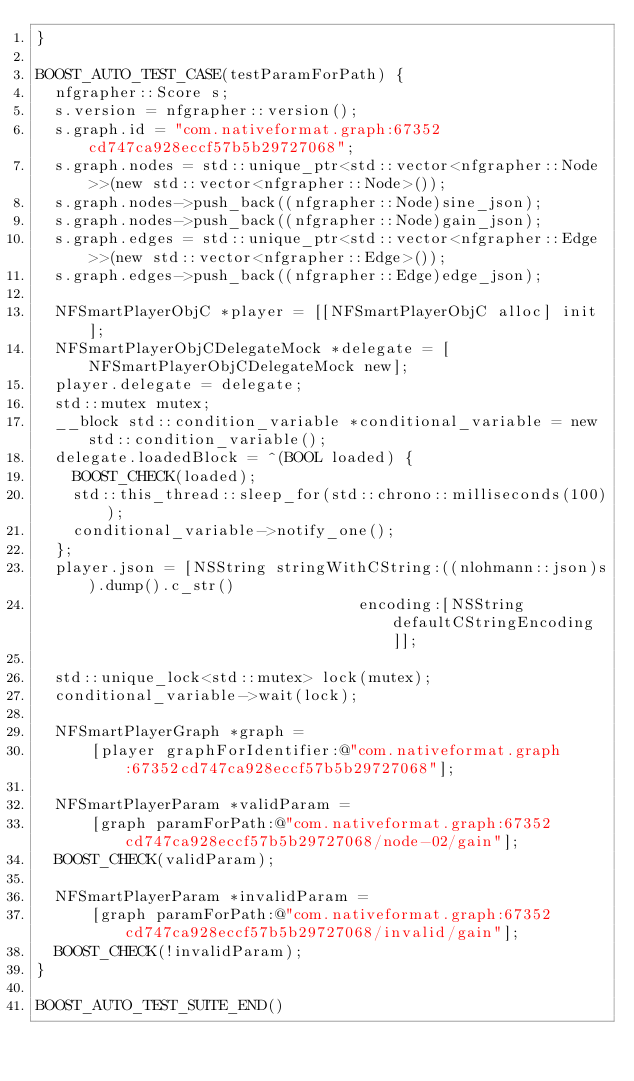Convert code to text. <code><loc_0><loc_0><loc_500><loc_500><_ObjectiveC_>}

BOOST_AUTO_TEST_CASE(testParamForPath) {
  nfgrapher::Score s;
  s.version = nfgrapher::version();
  s.graph.id = "com.nativeformat.graph:67352cd747ca928eccf57b5b29727068";
  s.graph.nodes = std::unique_ptr<std::vector<nfgrapher::Node>>(new std::vector<nfgrapher::Node>());
  s.graph.nodes->push_back((nfgrapher::Node)sine_json);
  s.graph.nodes->push_back((nfgrapher::Node)gain_json);
  s.graph.edges = std::unique_ptr<std::vector<nfgrapher::Edge>>(new std::vector<nfgrapher::Edge>());
  s.graph.edges->push_back((nfgrapher::Edge)edge_json);

  NFSmartPlayerObjC *player = [[NFSmartPlayerObjC alloc] init];
  NFSmartPlayerObjCDelegateMock *delegate = [NFSmartPlayerObjCDelegateMock new];
  player.delegate = delegate;
  std::mutex mutex;
  __block std::condition_variable *conditional_variable = new std::condition_variable();
  delegate.loadedBlock = ^(BOOL loaded) {
    BOOST_CHECK(loaded);
    std::this_thread::sleep_for(std::chrono::milliseconds(100));
    conditional_variable->notify_one();
  };
  player.json = [NSString stringWithCString:((nlohmann::json)s).dump().c_str()
                                   encoding:[NSString defaultCStringEncoding]];

  std::unique_lock<std::mutex> lock(mutex);
  conditional_variable->wait(lock);

  NFSmartPlayerGraph *graph =
      [player graphForIdentifier:@"com.nativeformat.graph:67352cd747ca928eccf57b5b29727068"];

  NFSmartPlayerParam *validParam =
      [graph paramForPath:@"com.nativeformat.graph:67352cd747ca928eccf57b5b29727068/node-02/gain"];
  BOOST_CHECK(validParam);

  NFSmartPlayerParam *invalidParam =
      [graph paramForPath:@"com.nativeformat.graph:67352cd747ca928eccf57b5b29727068/invalid/gain"];
  BOOST_CHECK(!invalidParam);
}

BOOST_AUTO_TEST_SUITE_END()
</code> 